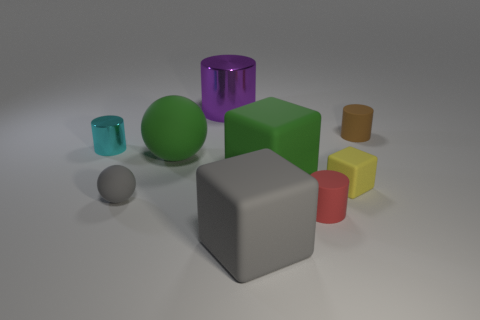Subtract all green cylinders. Subtract all gray cubes. How many cylinders are left? 4 Subtract all blocks. How many objects are left? 6 Subtract all big blue matte objects. Subtract all small gray objects. How many objects are left? 8 Add 3 tiny cubes. How many tiny cubes are left? 4 Add 3 small purple metallic balls. How many small purple metallic balls exist? 3 Subtract 0 gray cylinders. How many objects are left? 9 